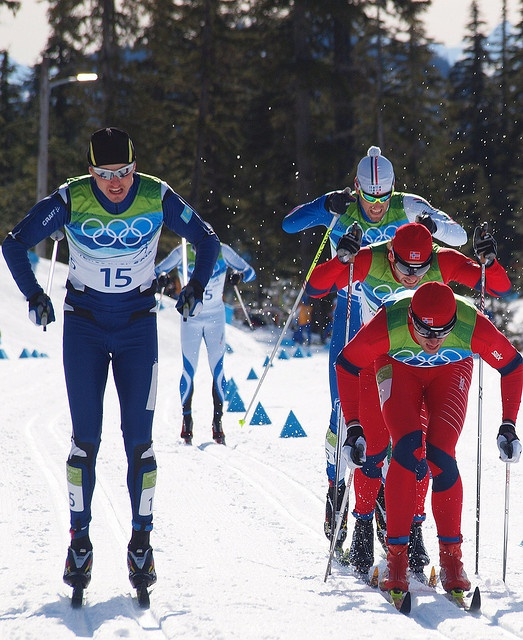Describe the objects in this image and their specific colors. I can see people in black, navy, darkgray, and lavender tones, people in black, brown, maroon, and navy tones, people in black, brown, maroon, and navy tones, people in black, blue, darkgray, and navy tones, and people in black, darkgray, white, and blue tones in this image. 